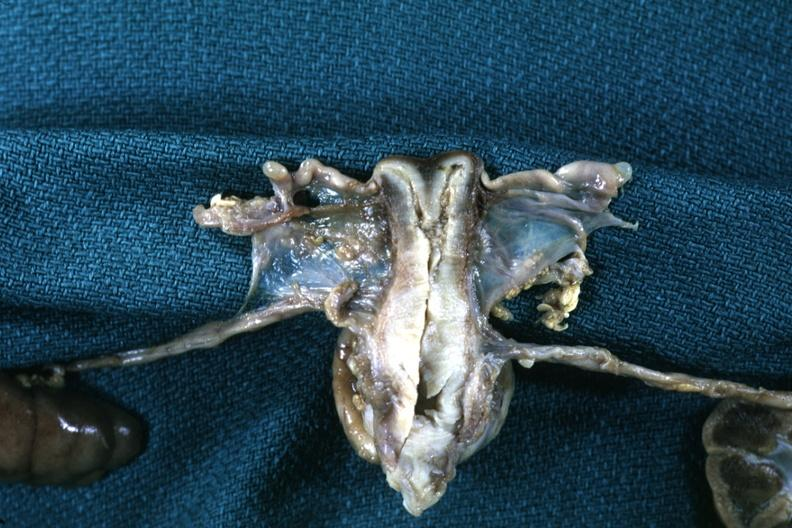where does this part belong to?
Answer the question using a single word or phrase. Female reproductive system 